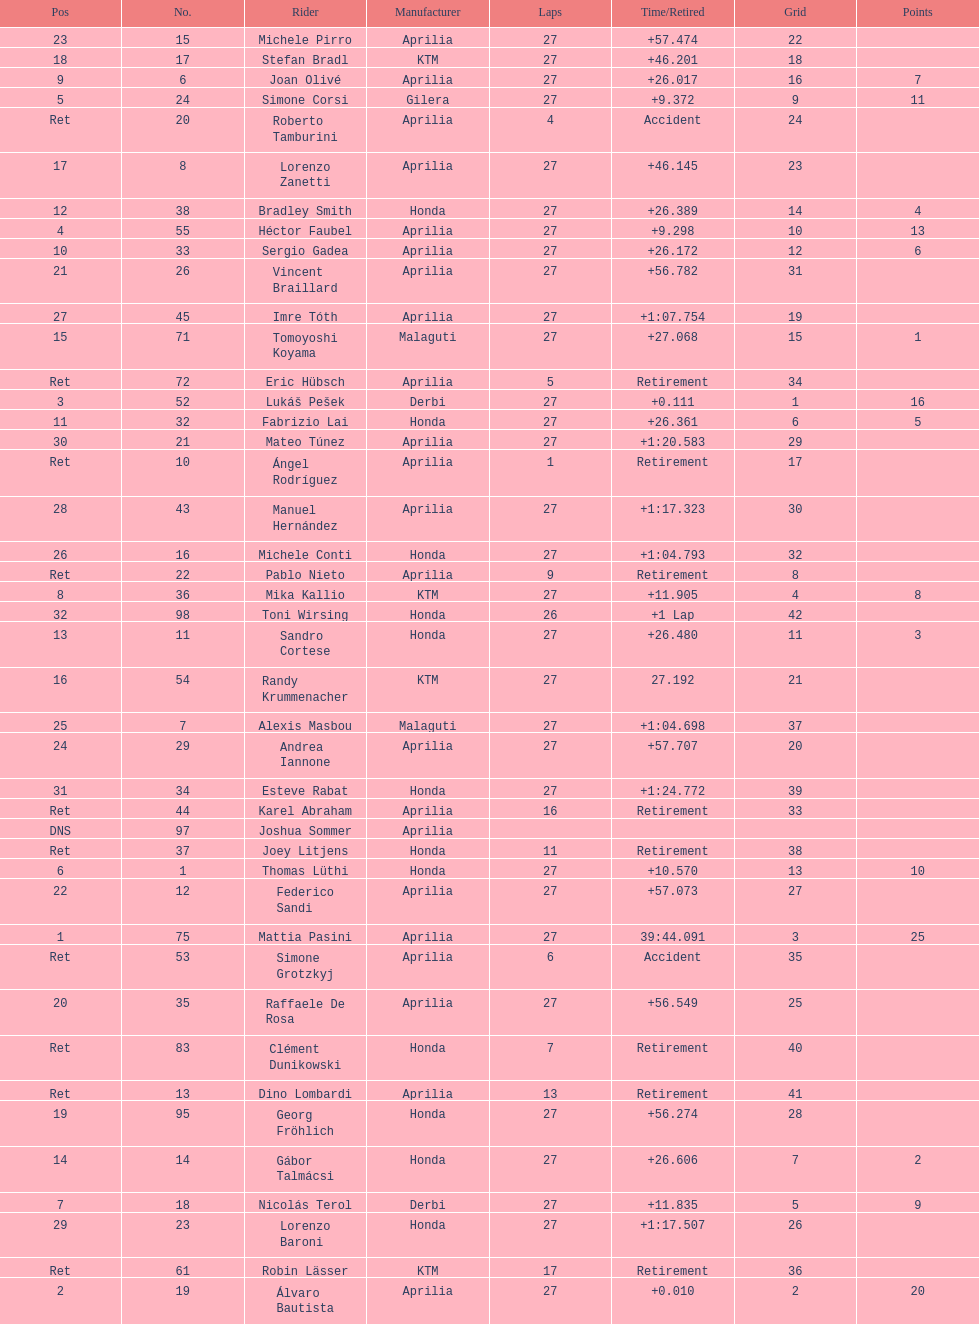How many german racers finished the race? 4. 